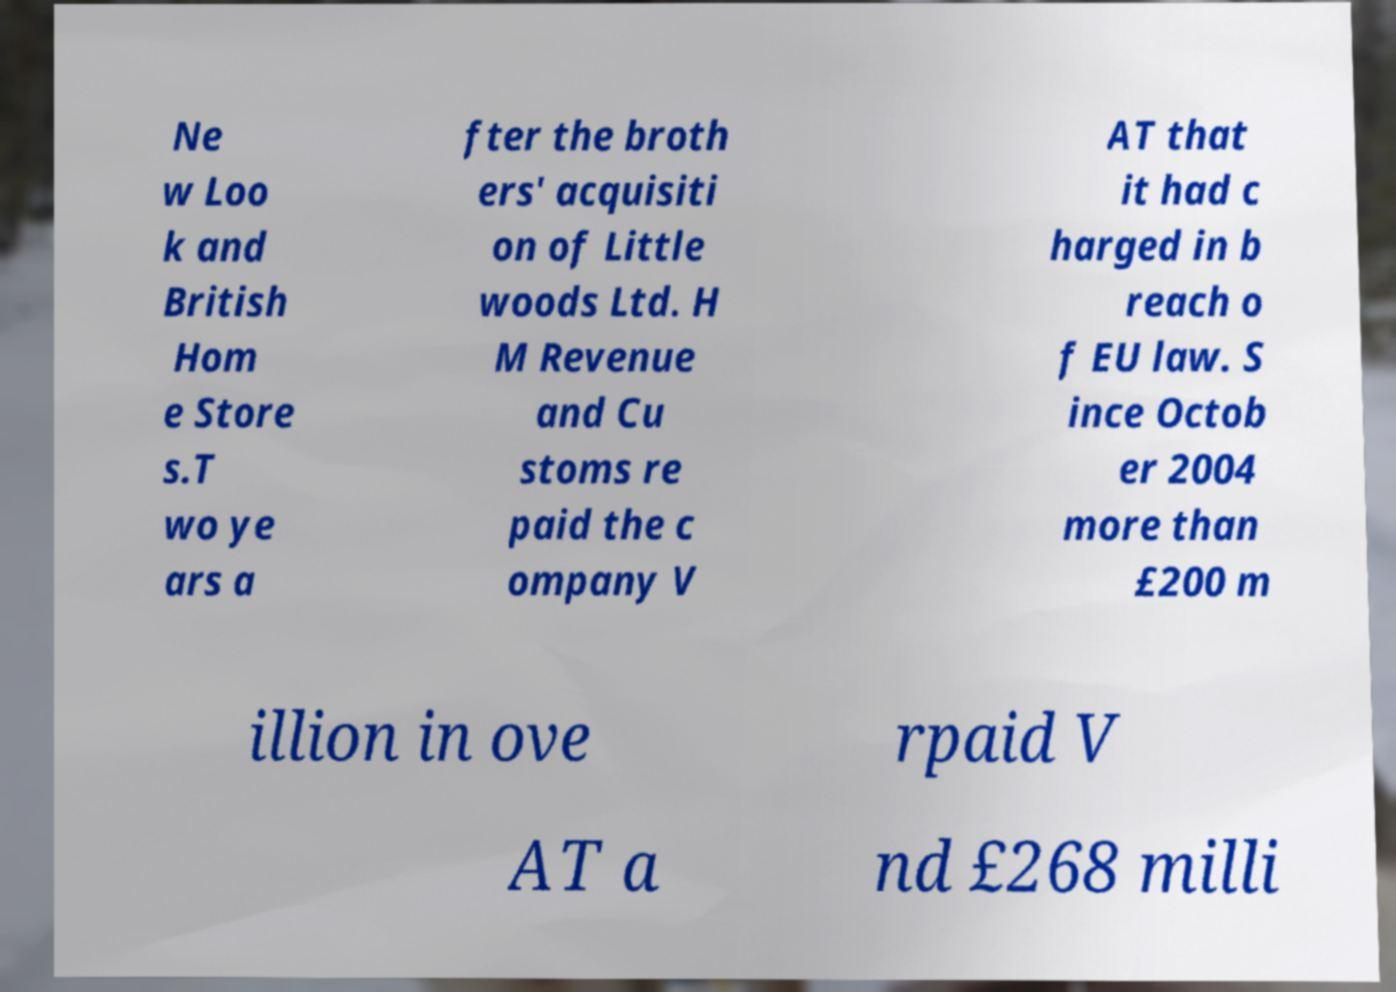Could you assist in decoding the text presented in this image and type it out clearly? Ne w Loo k and British Hom e Store s.T wo ye ars a fter the broth ers' acquisiti on of Little woods Ltd. H M Revenue and Cu stoms re paid the c ompany V AT that it had c harged in b reach o f EU law. S ince Octob er 2004 more than £200 m illion in ove rpaid V AT a nd £268 milli 